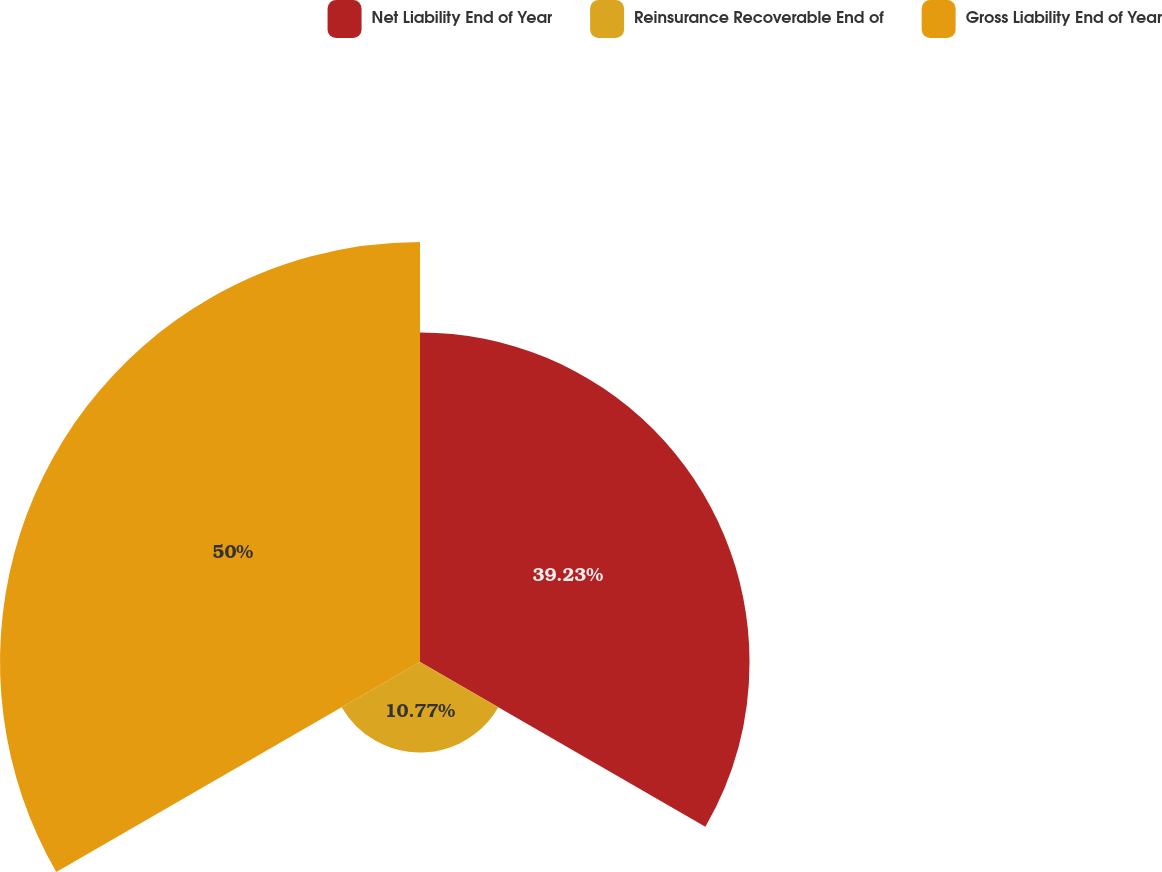Convert chart. <chart><loc_0><loc_0><loc_500><loc_500><pie_chart><fcel>Net Liability End of Year<fcel>Reinsurance Recoverable End of<fcel>Gross Liability End of Year<nl><fcel>39.23%<fcel>10.77%<fcel>50.0%<nl></chart> 